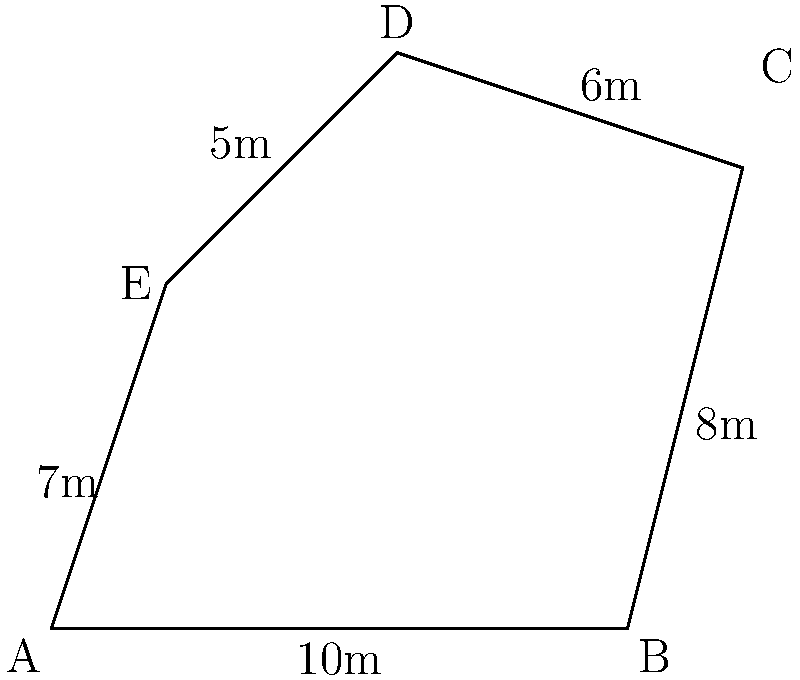You're planning to fence your irregularly shaped backyard. The diagram shows the shape and measurements of your yard. If you want to leave a 1-meter gap for a gate, estimate the total length of fencing required to the nearest meter. To estimate the total length of fencing required, we'll follow these steps:

1. Add up the lengths of all sides:
   $10 + 8 + 6 + 5 + 7 = 36$ meters

2. Subtract the 1-meter gap for the gate:
   $36 - 1 = 35$ meters

3. Round to the nearest meter:
   $35$ meters is already a whole number, so no rounding is necessary.

Therefore, the estimated length of fencing required is 35 meters.
Answer: 35 meters 